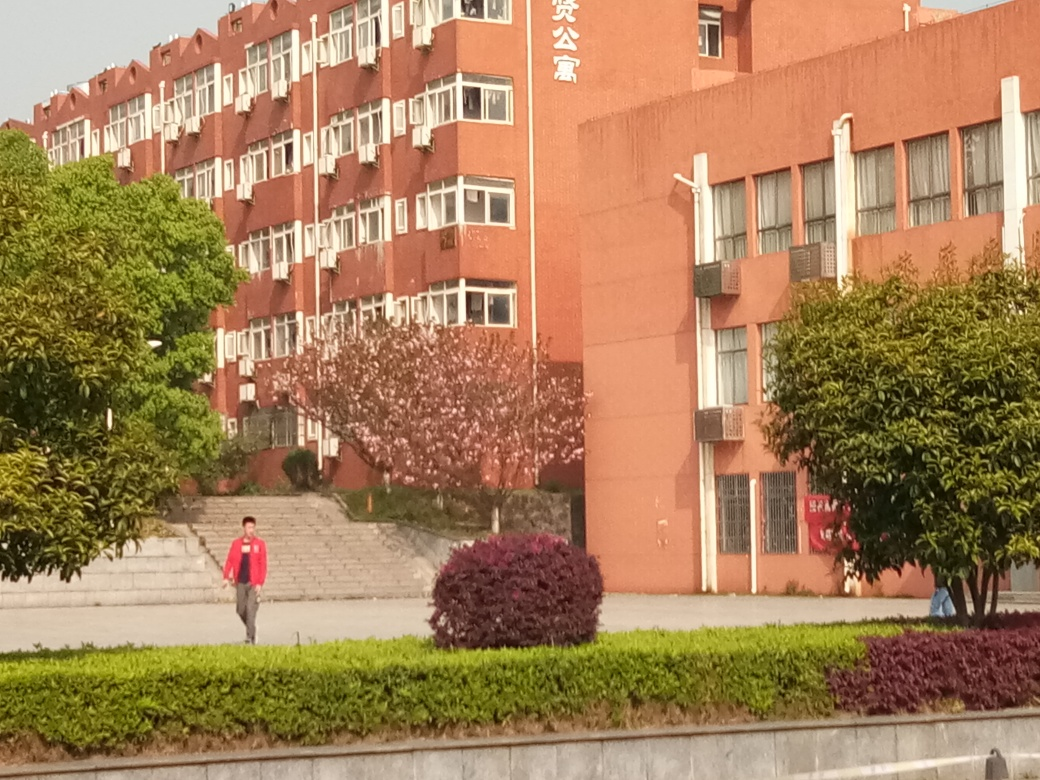What might the building in the image be used for? The building in the image has a robust and functional design, typical of an educational institution or a government facility. The presence of multiple air conditioning units suggests it could be a site requiring comfortable environments for work or study, potentially housing classrooms or offices. 